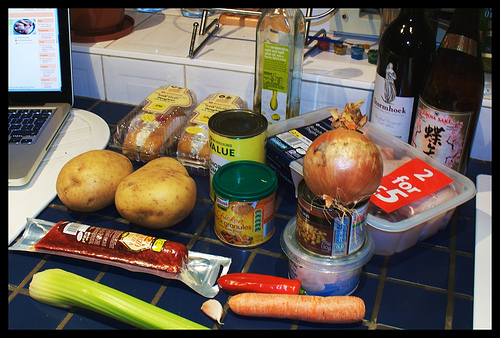<image>
Is the bottle on the can? No. The bottle is not positioned on the can. They may be near each other, but the bottle is not supported by or resting on top of the can. 